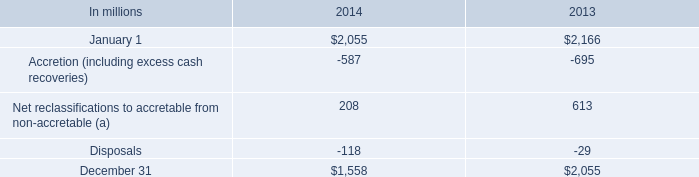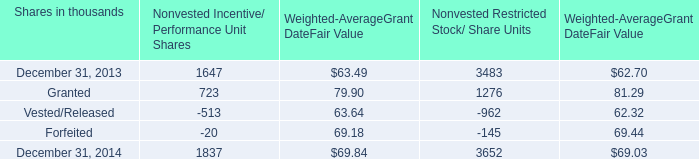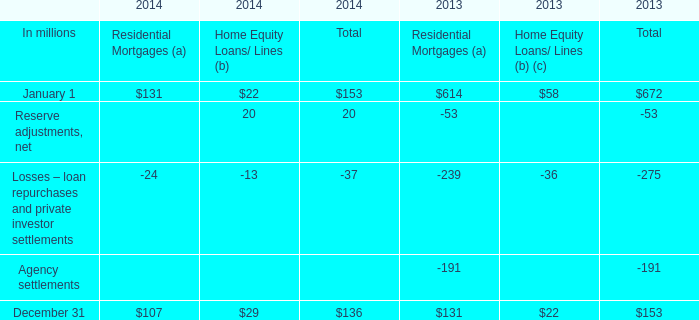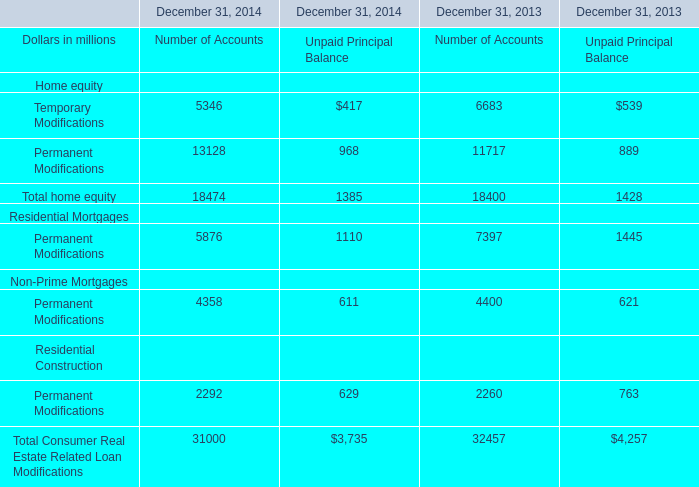what was the dollar amount in millions for net reclassifications for the year ended december 31 , 2013 due to the commercial portfolio? 
Computations: (2055 * 37%)
Answer: 760.35. 